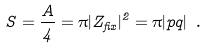<formula> <loc_0><loc_0><loc_500><loc_500>S = { \frac { A } { 4 } } = \pi | Z _ { f i x } | ^ { 2 } = \pi | p q | \ .</formula> 